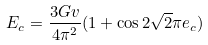<formula> <loc_0><loc_0><loc_500><loc_500>E _ { c } = \frac { 3 G v } { 4 \pi ^ { 2 } } ( 1 + \cos { 2 \sqrt { 2 } \pi e _ { c } } )</formula> 